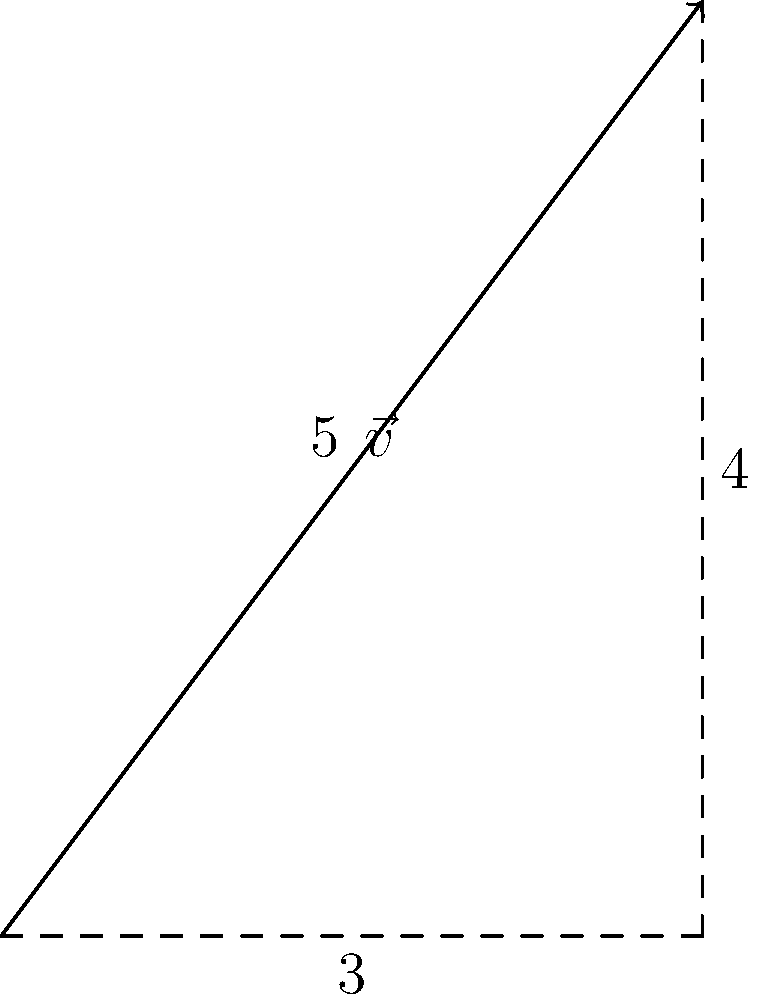In sentence structure analysis, consider a vector $\vec{v}$ representing the complexity of a sentence, where the x-component corresponds to the number of clauses and the y-component to the number of modifiers. If a particular sentence has 3 clauses and 4 modifiers, what is the magnitude of its complexity vector? To calculate the magnitude of the complexity vector, we can follow these steps:

1) The vector $\vec{v}$ is represented as $(3,4)$, where:
   - 3 represents the number of clauses (x-component)
   - 4 represents the number of modifiers (y-component)

2) The magnitude of a vector is calculated using the Pythagorean theorem:
   $\text{magnitude} = \sqrt{x^2 + y^2}$

3) Substituting our values:
   $\text{magnitude} = \sqrt{3^2 + 4^2}$

4) Simplify:
   $\text{magnitude} = \sqrt{9 + 16}$
   $\text{magnitude} = \sqrt{25}$

5) Calculate the square root:
   $\text{magnitude} = 5$

Therefore, the magnitude of the complexity vector for this sentence is 5.
Answer: 5 